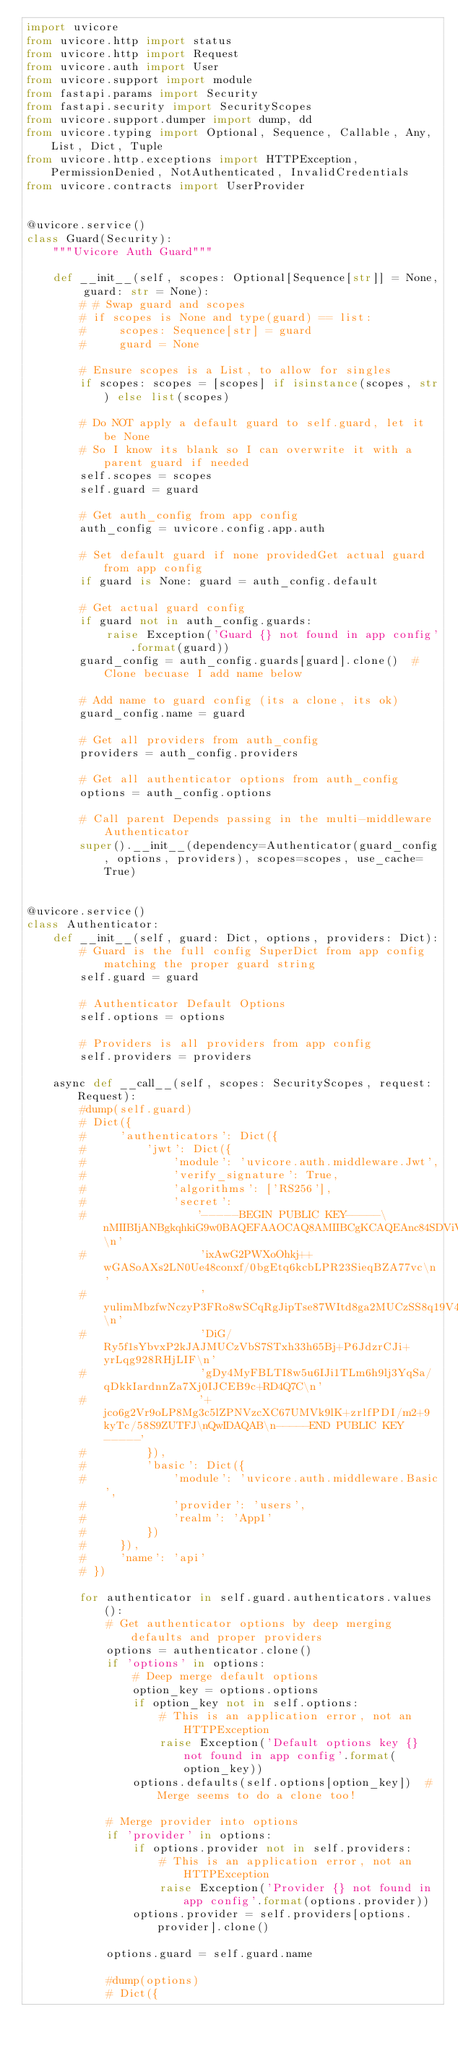Convert code to text. <code><loc_0><loc_0><loc_500><loc_500><_Python_>import uvicore
from uvicore.http import status
from uvicore.http import Request
from uvicore.auth import User
from uvicore.support import module
from fastapi.params import Security
from fastapi.security import SecurityScopes
from uvicore.support.dumper import dump, dd
from uvicore.typing import Optional, Sequence, Callable, Any, List, Dict, Tuple
from uvicore.http.exceptions import HTTPException, PermissionDenied, NotAuthenticated, InvalidCredentials
from uvicore.contracts import UserProvider


@uvicore.service()
class Guard(Security):
    """Uvicore Auth Guard"""

    def __init__(self, scopes: Optional[Sequence[str]] = None, guard: str = None):
        # # Swap guard and scopes
        # if scopes is None and type(guard) == list:
        #     scopes: Sequence[str] = guard
        #     guard = None

        # Ensure scopes is a List, to allow for singles
        if scopes: scopes = [scopes] if isinstance(scopes, str) else list(scopes)

        # Do NOT apply a default guard to self.guard, let it be None
        # So I know its blank so I can overwrite it with a parent guard if needed
        self.scopes = scopes
        self.guard = guard

        # Get auth_config from app config
        auth_config = uvicore.config.app.auth

        # Set default guard if none providedGet actual guard from app config
        if guard is None: guard = auth_config.default

        # Get actual guard config
        if guard not in auth_config.guards:
            raise Exception('Guard {} not found in app config'.format(guard))
        guard_config = auth_config.guards[guard].clone()  # Clone becuase I add name below

        # Add name to guard config (its a clone, its ok)
        guard_config.name = guard

        # Get all providers from auth_config
        providers = auth_config.providers

        # Get all authenticator options from auth_config
        options = auth_config.options

        # Call parent Depends passing in the multi-middleware Authenticator
        super().__init__(dependency=Authenticator(guard_config, options, providers), scopes=scopes, use_cache=True)


@uvicore.service()
class Authenticator:
    def __init__(self, guard: Dict, options, providers: Dict):
        # Guard is the full config SuperDict from app config matching the proper guard string
        self.guard = guard

        # Authenticator Default Options
        self.options = options

        # Providers is all providers from app config
        self.providers = providers

    async def __call__(self, scopes: SecurityScopes, request: Request):
        #dump(self.guard)
        # Dict({
        #     'authenticators': Dict({
        #         'jwt': Dict({
        #             'module': 'uvicore.auth.middleware.Jwt',
        #             'verify_signature': True,
        #             'algorithms': ['RS256'],
        #             'secret':
        #                 '-----BEGIN PUBLIC KEY-----\nMIIBIjANBgkqhkiG9w0BAQEFAAOCAQ8AMIIBCgKCAQEAnc84SDViVX8JNye2GVQZ\n'
        #                 'ixAwG2PWXoOhkj++wGASoAXs2LN0Ue48conxf/0bgEtq6kcbLPR23SieqBZA77vc\n'
        #                 'yulimMbzfwNczyP3FRo8wSCqRgJipTse87WItd8ga2MUCzSS8q19V4swUT4T23Su\n'
        #                 'DiG/Ry5f1sYbvxP2kJAJMUCzVbS7STxh33h65Bj+P6JdzrCJi+yrLqg928RHjLIF\n'
        #                 'gDy4MyFBLTI8w5u6IJi1TLm6h9lj3YqSa/qDkkIardnnZa7Xj0IJCEB9c+RD4Q7C\n'
        #                 '+jco6g2Vr9oLP8Mg3c5lZPNVzcXC67UMVk9lK+zrlfPDI/m2+9kyTc/58S9ZUTFJ\nQwIDAQAB\n-----END PUBLIC KEY-----'
        #         }),
        #         'basic': Dict({
        #             'module': 'uvicore.auth.middleware.Basic',
        #             'provider': 'users',
        #             'realm': 'App1'
        #         })
        #     }),
        #     'name': 'api'
        # })

        for authenticator in self.guard.authenticators.values():
            # Get authenticator options by deep merging defaults and proper providers
            options = authenticator.clone()
            if 'options' in options:
                # Deep merge default options
                option_key = options.options
                if option_key not in self.options:
                    # This is an application error, not an HTTPException
                    raise Exception('Default options key {} not found in app config'.format(option_key))
                options.defaults(self.options[option_key])  # Merge seems to do a clone too!

            # Merge provider into options
            if 'provider' in options:
                if options.provider not in self.providers:
                    # This is an application error, not an HTTPException
                    raise Exception('Provider {} not found in app config'.format(options.provider))
                options.provider = self.providers[options.provider].clone()

            options.guard = self.guard.name

            #dump(options)
            # Dict({</code> 